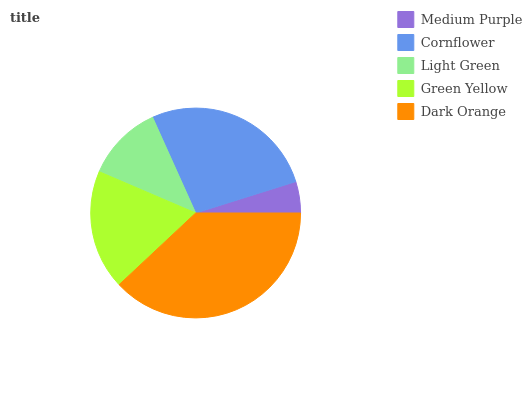Is Medium Purple the minimum?
Answer yes or no. Yes. Is Dark Orange the maximum?
Answer yes or no. Yes. Is Cornflower the minimum?
Answer yes or no. No. Is Cornflower the maximum?
Answer yes or no. No. Is Cornflower greater than Medium Purple?
Answer yes or no. Yes. Is Medium Purple less than Cornflower?
Answer yes or no. Yes. Is Medium Purple greater than Cornflower?
Answer yes or no. No. Is Cornflower less than Medium Purple?
Answer yes or no. No. Is Green Yellow the high median?
Answer yes or no. Yes. Is Green Yellow the low median?
Answer yes or no. Yes. Is Light Green the high median?
Answer yes or no. No. Is Cornflower the low median?
Answer yes or no. No. 